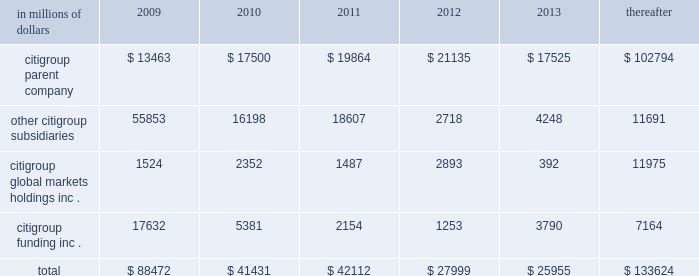Cgmhi also has substantial borrowing arrangements consisting of facilities that cgmhi has been advised are available , but where no contractual lending obligation exists .
These arrangements are reviewed on an ongoing basis to ensure flexibility in meeting cgmhi 2019s short-term requirements .
The company issues both fixed and variable rate debt in a range of currencies .
It uses derivative contracts , primarily interest rate swaps , to effectively convert a portion of its fixed rate debt to variable rate debt and variable rate debt to fixed rate debt .
The maturity structure of the derivatives generally corresponds to the maturity structure of the debt being hedged .
In addition , the company uses other derivative contracts to manage the foreign exchange impact of certain debt issuances .
At december 31 , 2008 , the company 2019s overall weighted average interest rate for long-term debt was 3.83% ( 3.83 % ) on a contractual basis and 4.19% ( 4.19 % ) including the effects of derivative contracts .
Aggregate annual maturities of long-term debt obligations ( based on final maturity dates ) including trust preferred securities are as follows : in millions of dollars 2009 2010 2011 2012 2013 thereafter .
Long-term debt at december 31 , 2008 and december 31 , 2007 includes $ 24060 million and $ 23756 million , respectively , of junior subordinated debt .
The company formed statutory business trusts under the laws of the state of delaware .
The trusts exist for the exclusive purposes of ( i ) issuing trust securities representing undivided beneficial interests in the assets of the trust ; ( ii ) investing the gross proceeds of the trust securities in junior subordinated deferrable interest debentures ( subordinated debentures ) of its parent ; and ( iii ) engaging in only those activities necessary or incidental thereto .
Upon approval from the federal reserve , citigroup has the right to redeem these securities .
Citigroup has contractually agreed not to redeem or purchase ( i ) the 6.50% ( 6.50 % ) enhanced trust preferred securities of citigroup capital xv before september 15 , 2056 , ( ii ) the 6.45% ( 6.45 % ) enhanced trust preferred securities of citigroup capital xvi before december 31 , 2046 , ( iii ) the 6.35% ( 6.35 % ) enhanced trust preferred securities of citigroup capital xvii before march 15 , 2057 , ( iv ) the 6.829% ( 6.829 % ) fixed rate/floating rate enhanced trust preferred securities of citigroup capital xviii before june 28 , 2047 , ( v ) the 7.250% ( 7.250 % ) enhanced trust preferred securities of citigroup capital xix before august 15 , 2047 , ( vi ) the 7.875% ( 7.875 % ) enhanced trust preferred securities of citigroup capital xx before december 15 , 2067 , and ( vii ) the 8.300% ( 8.300 % ) fixed rate/floating rate enhanced trust preferred securities of citigroup capital xxi before december 21 , 2067 unless certain conditions , described in exhibit 4.03 to citigroup 2019s current report on form 8-k filed on september 18 , 2006 , in exhibit 4.02 to citigroup 2019s current report on form 8-k filed on november 28 , 2006 , in exhibit 4.02 to citigroup 2019s current report on form 8-k filed on march 8 , 2007 , in exhibit 4.02 to citigroup 2019s current report on form 8-k filed on july 2 , 2007 , in exhibit 4.02 to citigroup 2019s current report on form 8-k filed on august 17 , 2007 , in exhibit 4.2 to citigroup 2019s current report on form 8-k filed on november 27 , 2007 , and in exhibit 4.2 to citigroup 2019s current report on form 8-k filed on december 21 , 2007 , respectively , are met .
These agreements are for the benefit of the holders of citigroup 2019s 6.00% ( 6.00 % ) junior subordinated deferrable interest debentures due 2034 .
Citigroup owns all of the voting securities of these subsidiary trusts .
These subsidiary trusts have no assets , operations , revenues or cash flows other than those related to the issuance , administration and repayment of the subsidiary trusts and the subsidiary trusts 2019 common securities .
These subsidiary trusts 2019 obligations are fully and unconditionally guaranteed by citigroup. .
What was the percent decrease in the total aggregate annual maturities of long-term debt obligations from 2011 to 2012? 
Computations: ((27999 - 42112) / 42112)
Answer: -0.33513. 